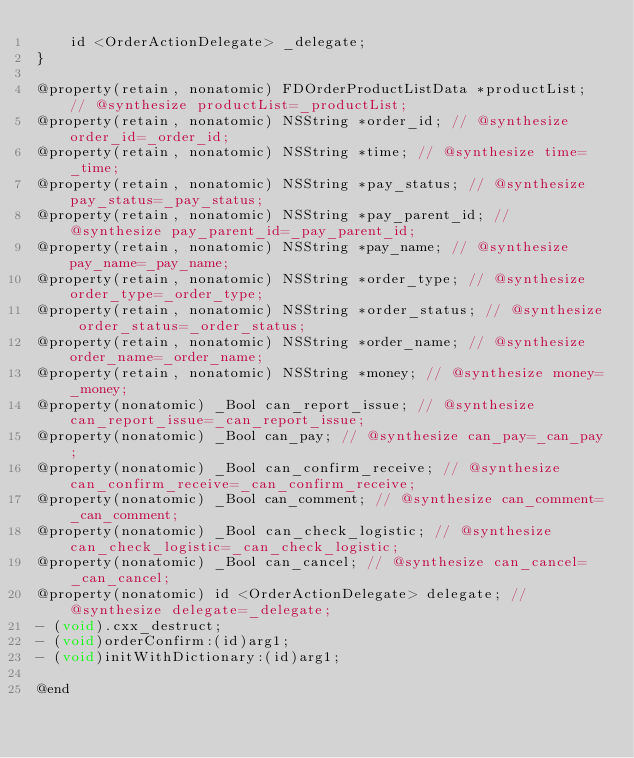Convert code to text. <code><loc_0><loc_0><loc_500><loc_500><_C_>    id <OrderActionDelegate> _delegate;
}

@property(retain, nonatomic) FDOrderProductListData *productList; // @synthesize productList=_productList;
@property(retain, nonatomic) NSString *order_id; // @synthesize order_id=_order_id;
@property(retain, nonatomic) NSString *time; // @synthesize time=_time;
@property(retain, nonatomic) NSString *pay_status; // @synthesize pay_status=_pay_status;
@property(retain, nonatomic) NSString *pay_parent_id; // @synthesize pay_parent_id=_pay_parent_id;
@property(retain, nonatomic) NSString *pay_name; // @synthesize pay_name=_pay_name;
@property(retain, nonatomic) NSString *order_type; // @synthesize order_type=_order_type;
@property(retain, nonatomic) NSString *order_status; // @synthesize order_status=_order_status;
@property(retain, nonatomic) NSString *order_name; // @synthesize order_name=_order_name;
@property(retain, nonatomic) NSString *money; // @synthesize money=_money;
@property(nonatomic) _Bool can_report_issue; // @synthesize can_report_issue=_can_report_issue;
@property(nonatomic) _Bool can_pay; // @synthesize can_pay=_can_pay;
@property(nonatomic) _Bool can_confirm_receive; // @synthesize can_confirm_receive=_can_confirm_receive;
@property(nonatomic) _Bool can_comment; // @synthesize can_comment=_can_comment;
@property(nonatomic) _Bool can_check_logistic; // @synthesize can_check_logistic=_can_check_logistic;
@property(nonatomic) _Bool can_cancel; // @synthesize can_cancel=_can_cancel;
@property(nonatomic) id <OrderActionDelegate> delegate; // @synthesize delegate=_delegate;
- (void).cxx_destruct;
- (void)orderConfirm:(id)arg1;
- (void)initWithDictionary:(id)arg1;

@end

</code> 